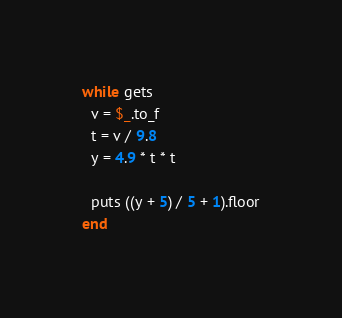<code> <loc_0><loc_0><loc_500><loc_500><_Ruby_>while gets
  v = $_.to_f
  t = v / 9.8
  y = 4.9 * t * t

  puts ((y + 5) / 5 + 1).floor
end</code> 